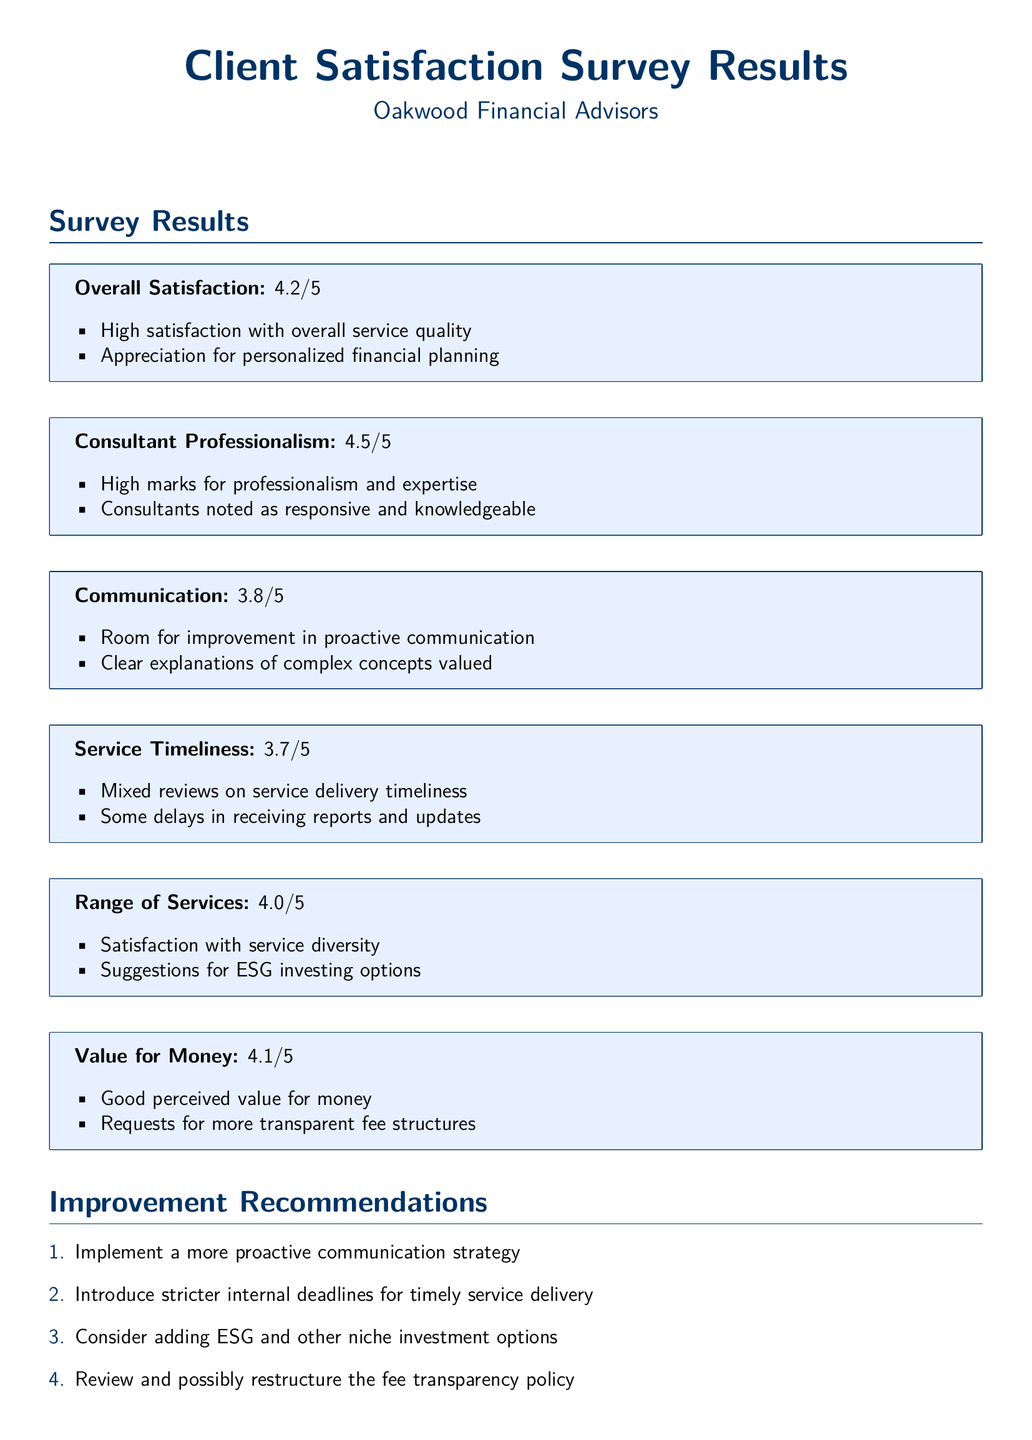What is the overall satisfaction rating? The overall satisfaction rating is presented as 4.2 out of 5 in the document.
Answer: 4.2/5 What is the rating for consultant professionalism? The rating for consultant professionalism is shown as 4.5 out of 5.
Answer: 4.5/5 What specific area received a 3.8 rating? The document indicates that communication received a rating of 3.8 out of 5.
Answer: Communication What recommendation is made regarding service delivery? One recommendation is to introduce stricter internal deadlines for timely service delivery, which is emphasized in the improvement recommendations.
Answer: Stricter internal deadlines What aspect of services do clients want added? Clients have suggested adding ESG investing options, reflecting their desire for more diverse investment options.
Answer: ESG investing options What is the rating for value for money? The rating for value for money is stated as 4.1 out of 5.
Answer: 4.1/5 What area has mixed reviews in the survey? The survey indicates that service timeliness received mixed reviews, highlighting some inconsistencies in this area.
Answer: Service timeliness What is one client request related to fees? Clients have requested for more transparent fee structures, which is noted in the value for money section.
Answer: More transparent fee structures 